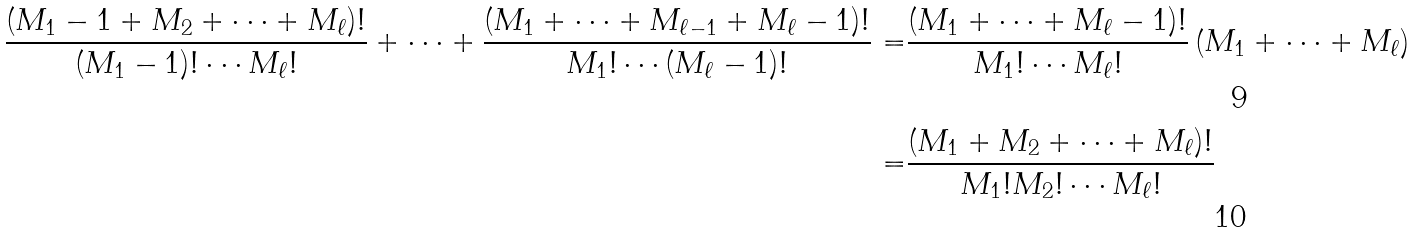Convert formula to latex. <formula><loc_0><loc_0><loc_500><loc_500>\frac { ( M _ { 1 } - 1 + M _ { 2 } + \cdots + M _ { \ell } ) ! } { ( M _ { 1 } - 1 ) ! \cdots M _ { \ell } ! } + \cdots + \frac { ( M _ { 1 } + \cdots + M _ { \ell - 1 } + M _ { \ell } - 1 ) ! } { M _ { 1 } ! \cdots ( M _ { \ell } - 1 ) ! } = & \frac { ( M _ { 1 } + \cdots + M _ { \ell } - 1 ) ! } { M _ { 1 } ! \cdots M _ { \ell } ! } \left ( M _ { 1 } + \cdots + M _ { \ell } \right ) \\ = & \frac { ( M _ { 1 } + M _ { 2 } + \cdots + M _ { \ell } ) ! } { M _ { 1 } ! M _ { 2 } ! \cdots M _ { \ell } ! }</formula> 